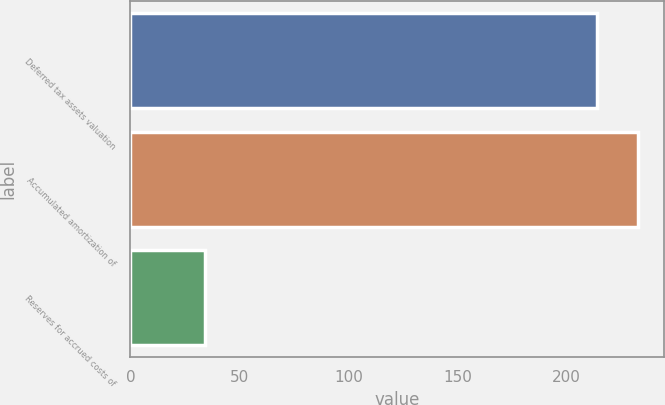<chart> <loc_0><loc_0><loc_500><loc_500><bar_chart><fcel>Deferred tax assets valuation<fcel>Accumulated amortization of<fcel>Reserves for accrued costs of<nl><fcel>214<fcel>232.7<fcel>34<nl></chart> 